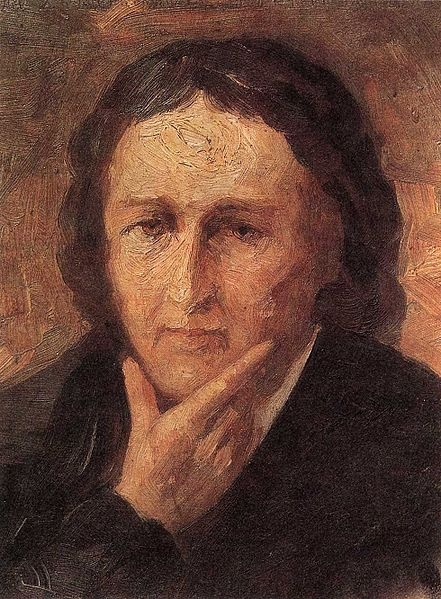What might the person in the painting be thinking about? The individual in the painting might be deep in thought about personal memories or significant life events. The reflective pose and somber expression suggest they could be contemplating past struggles or profound life questions, perhaps pondering over their life choices or future ambitions. 